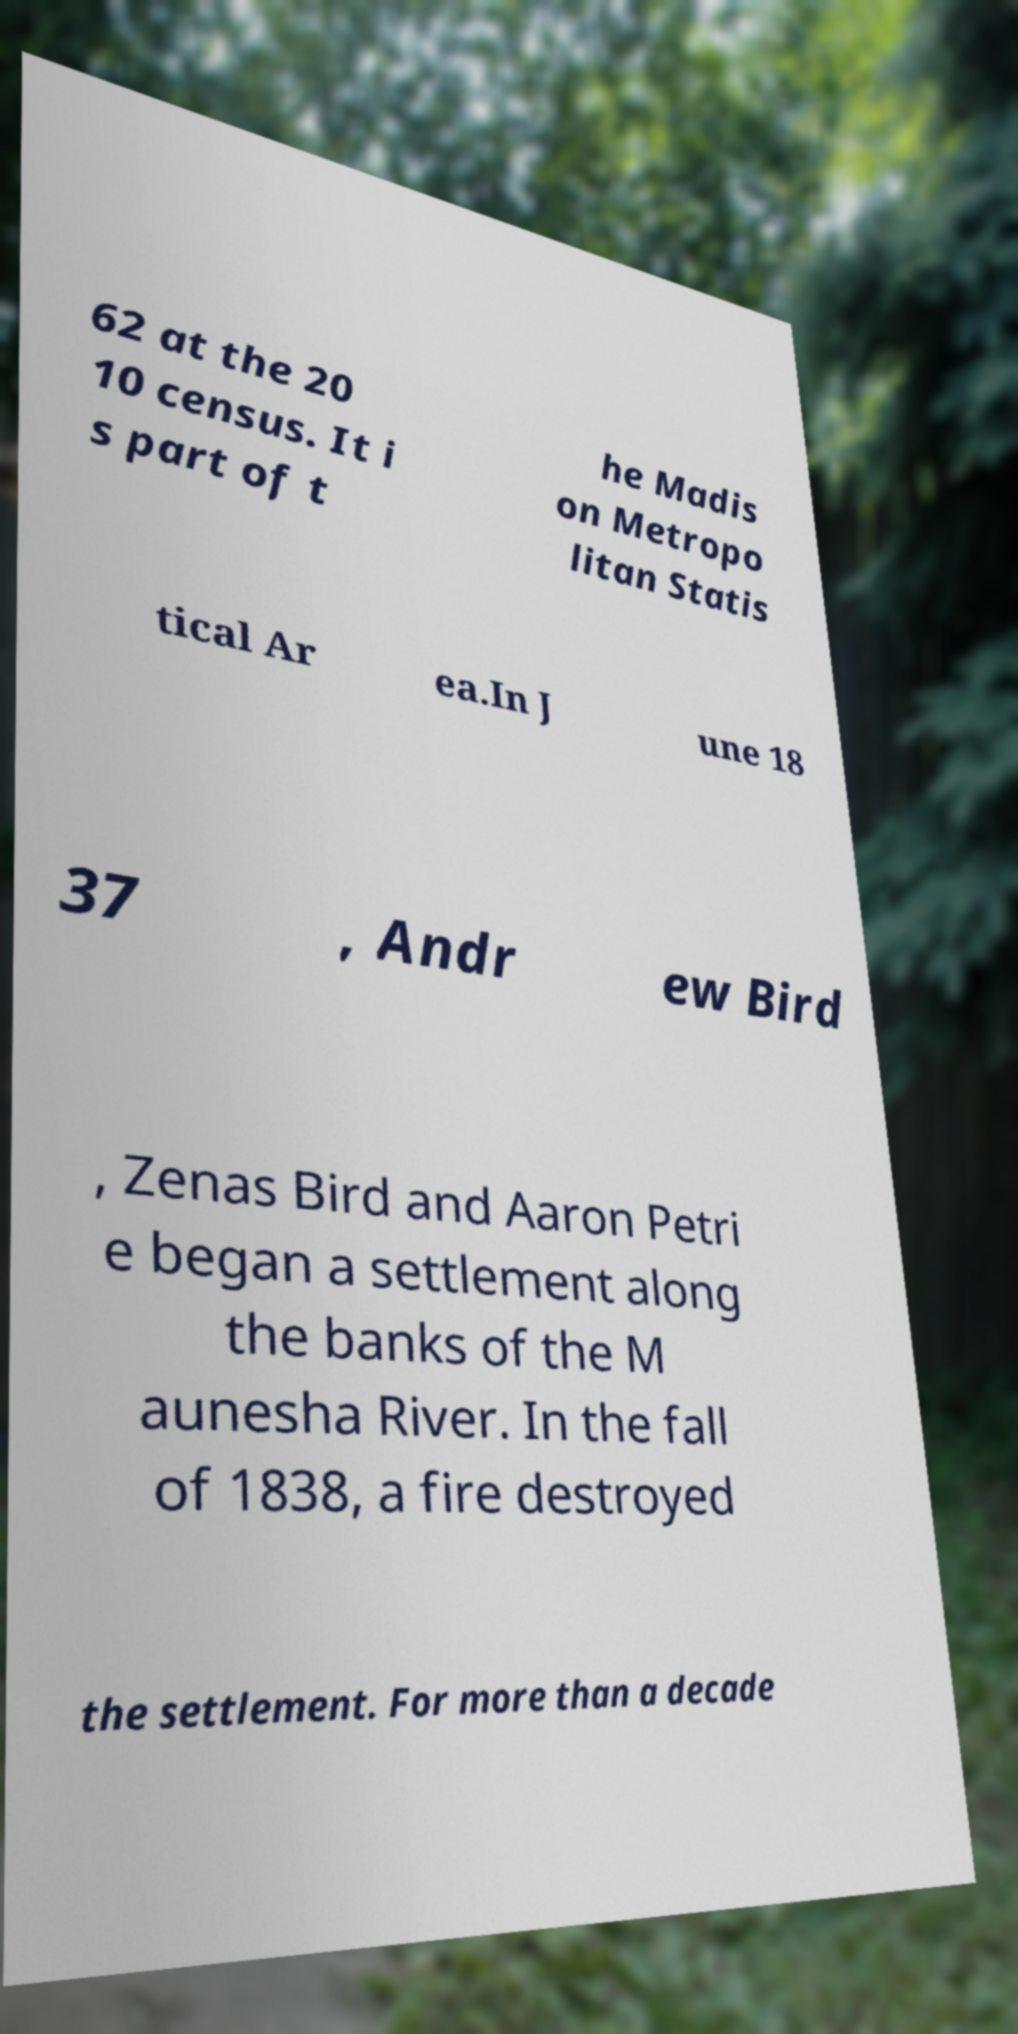Please identify and transcribe the text found in this image. 62 at the 20 10 census. It i s part of t he Madis on Metropo litan Statis tical Ar ea.In J une 18 37 , Andr ew Bird , Zenas Bird and Aaron Petri e began a settlement along the banks of the M aunesha River. In the fall of 1838, a fire destroyed the settlement. For more than a decade 